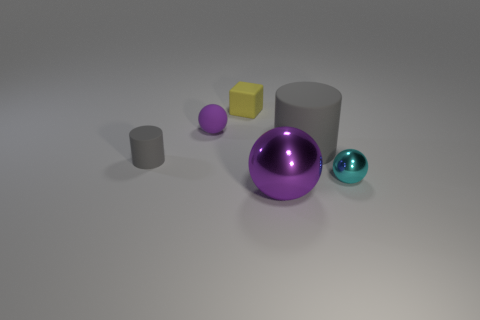Are there the same number of matte cubes that are on the right side of the small yellow block and gray balls?
Your answer should be compact. Yes. There is a shiny thing that is the same size as the yellow matte block; what is its shape?
Your answer should be very brief. Sphere. What is the material of the large gray object?
Your answer should be very brief. Rubber. What color is the thing that is both behind the small gray object and on the left side of the small yellow matte object?
Make the answer very short. Purple. Are there an equal number of tiny things on the left side of the small yellow matte thing and yellow objects on the right side of the cyan metal ball?
Your answer should be very brief. No. The small cylinder that is made of the same material as the large gray cylinder is what color?
Give a very brief answer. Gray. There is a rubber ball; is it the same color as the metallic sphere in front of the cyan sphere?
Your response must be concise. Yes. Is there a big metallic ball on the right side of the cylinder to the right of the gray cylinder to the left of the large gray object?
Keep it short and to the point. No. The tiny purple object that is made of the same material as the yellow thing is what shape?
Make the answer very short. Sphere. Is there any other thing that is the same shape as the big purple thing?
Your answer should be compact. Yes. 